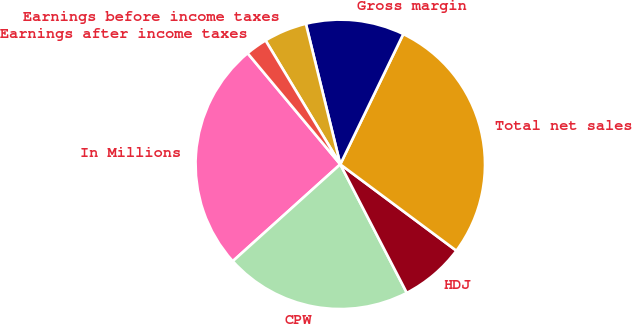Convert chart to OTSL. <chart><loc_0><loc_0><loc_500><loc_500><pie_chart><fcel>In Millions<fcel>CPW<fcel>HDJ<fcel>Total net sales<fcel>Gross margin<fcel>Earnings before income taxes<fcel>Earnings after income taxes<nl><fcel>25.61%<fcel>20.93%<fcel>7.22%<fcel>28.01%<fcel>10.99%<fcel>4.82%<fcel>2.42%<nl></chart> 